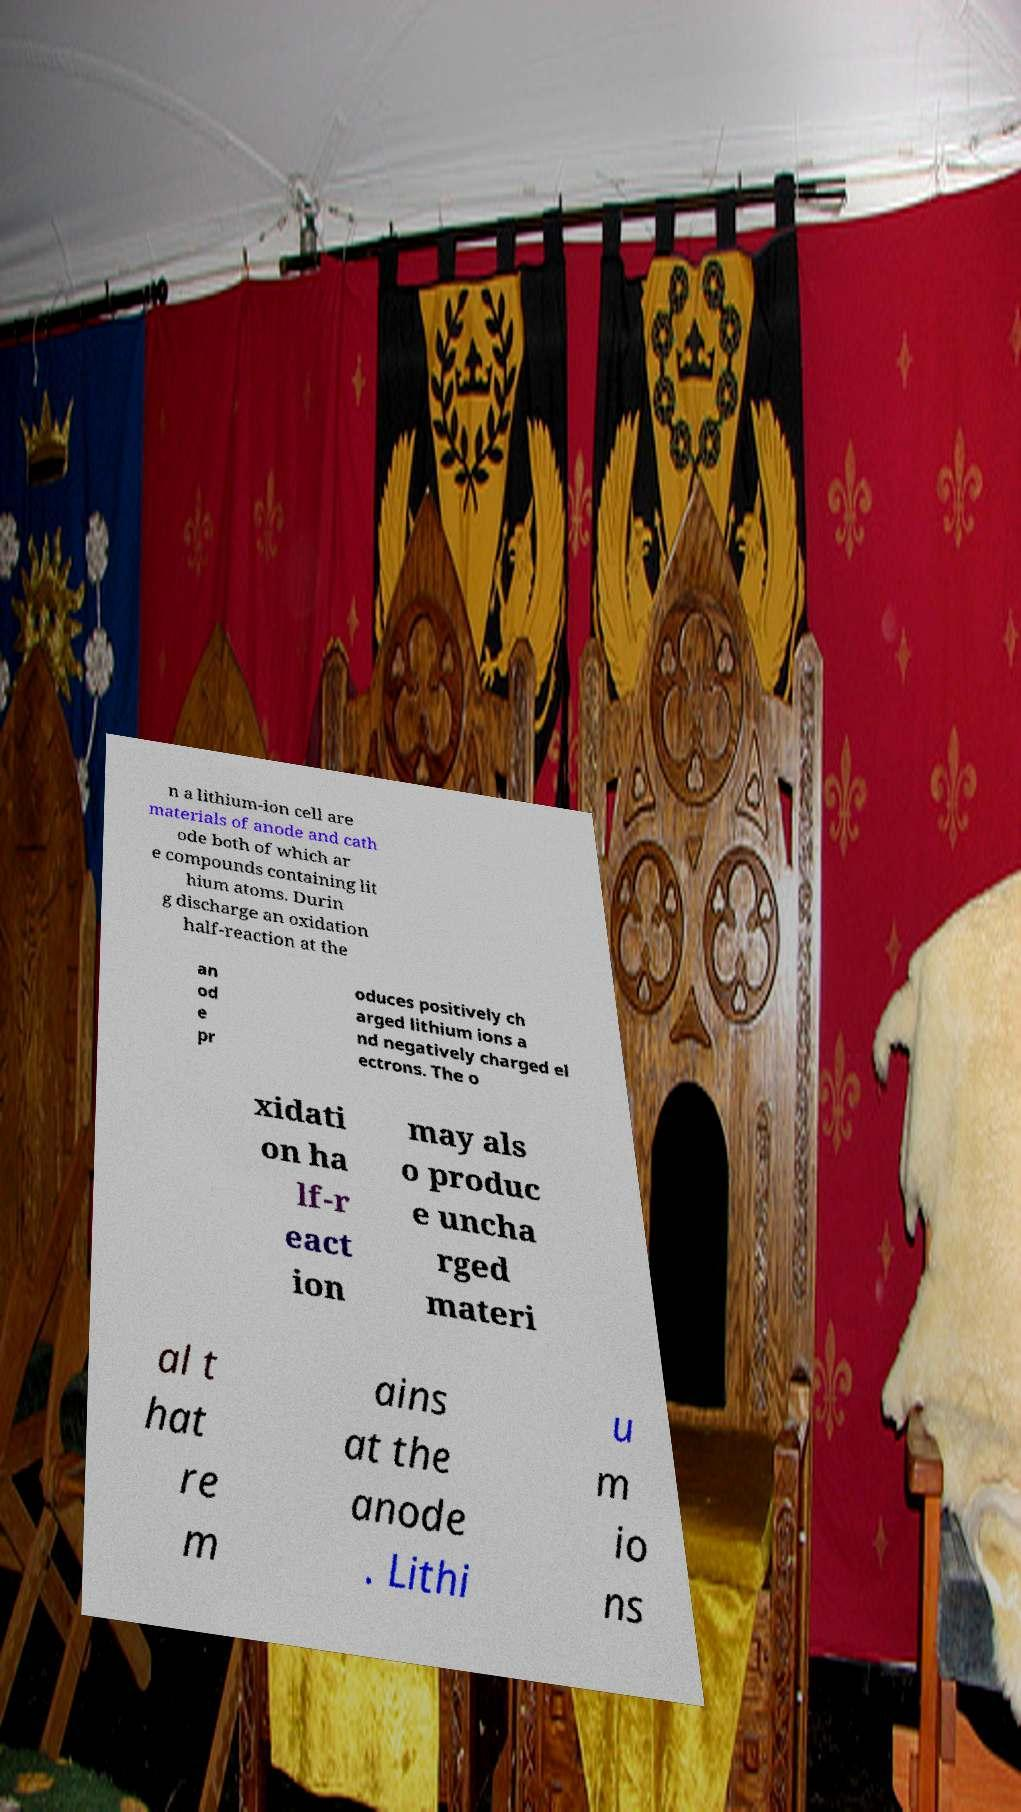Could you assist in decoding the text presented in this image and type it out clearly? n a lithium-ion cell are materials of anode and cath ode both of which ar e compounds containing lit hium atoms. Durin g discharge an oxidation half-reaction at the an od e pr oduces positively ch arged lithium ions a nd negatively charged el ectrons. The o xidati on ha lf-r eact ion may als o produc e uncha rged materi al t hat re m ains at the anode . Lithi u m io ns 